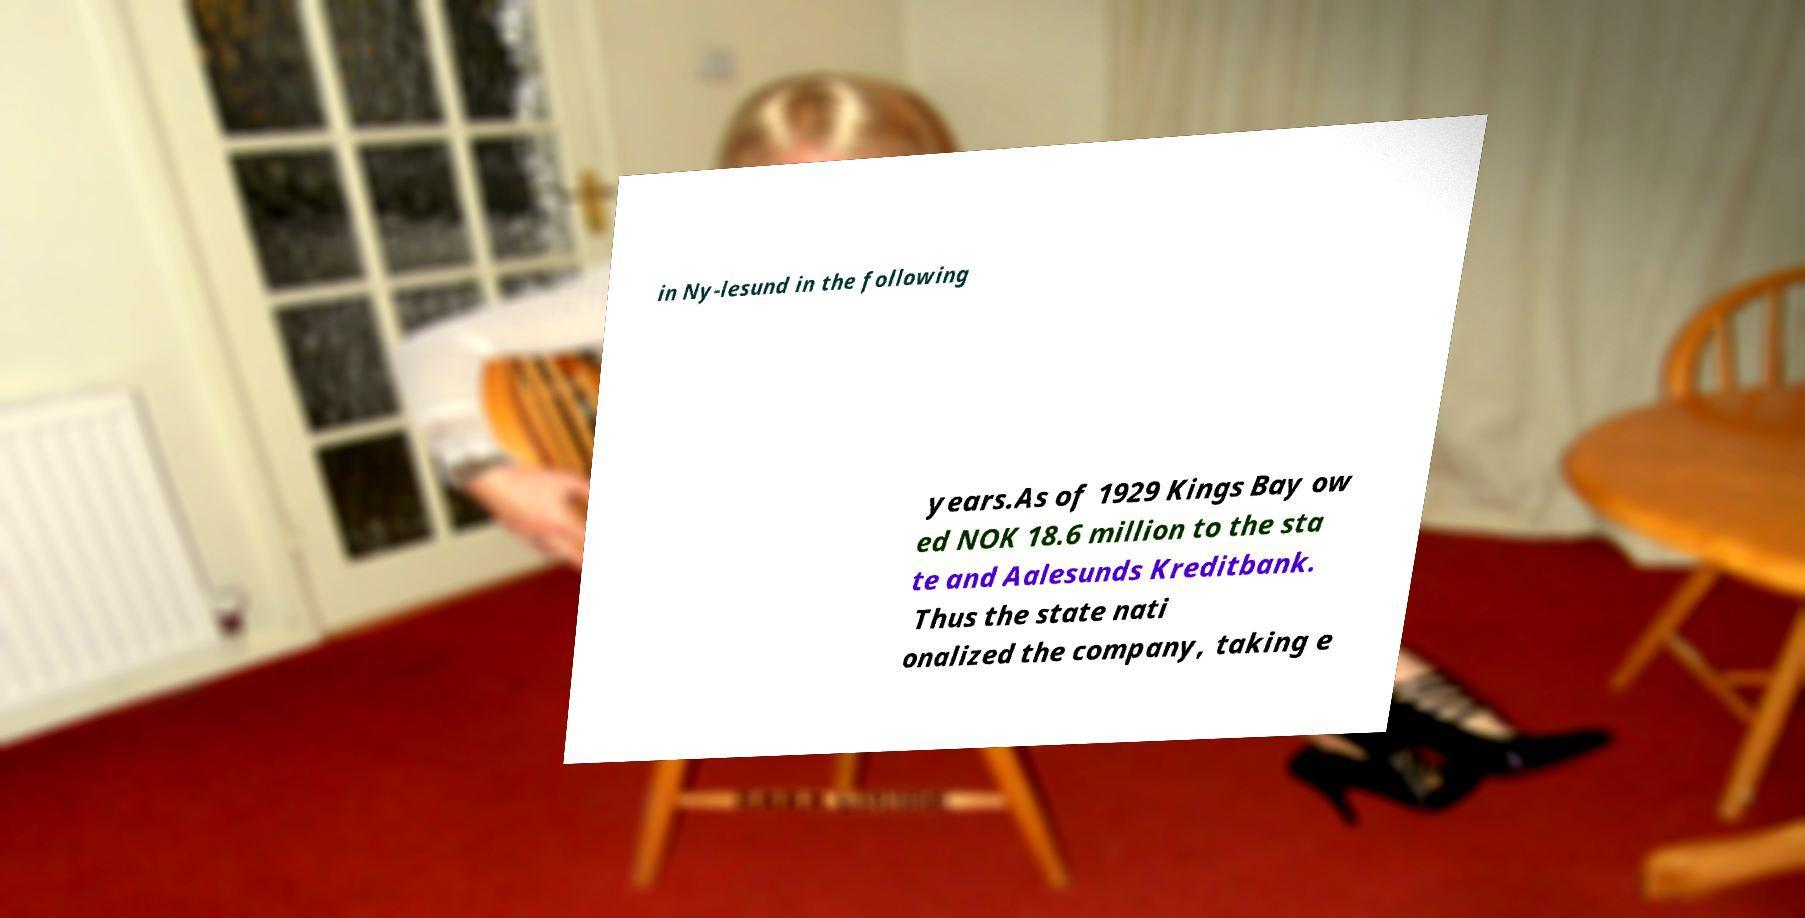Could you assist in decoding the text presented in this image and type it out clearly? in Ny-lesund in the following years.As of 1929 Kings Bay ow ed NOK 18.6 million to the sta te and Aalesunds Kreditbank. Thus the state nati onalized the company, taking e 